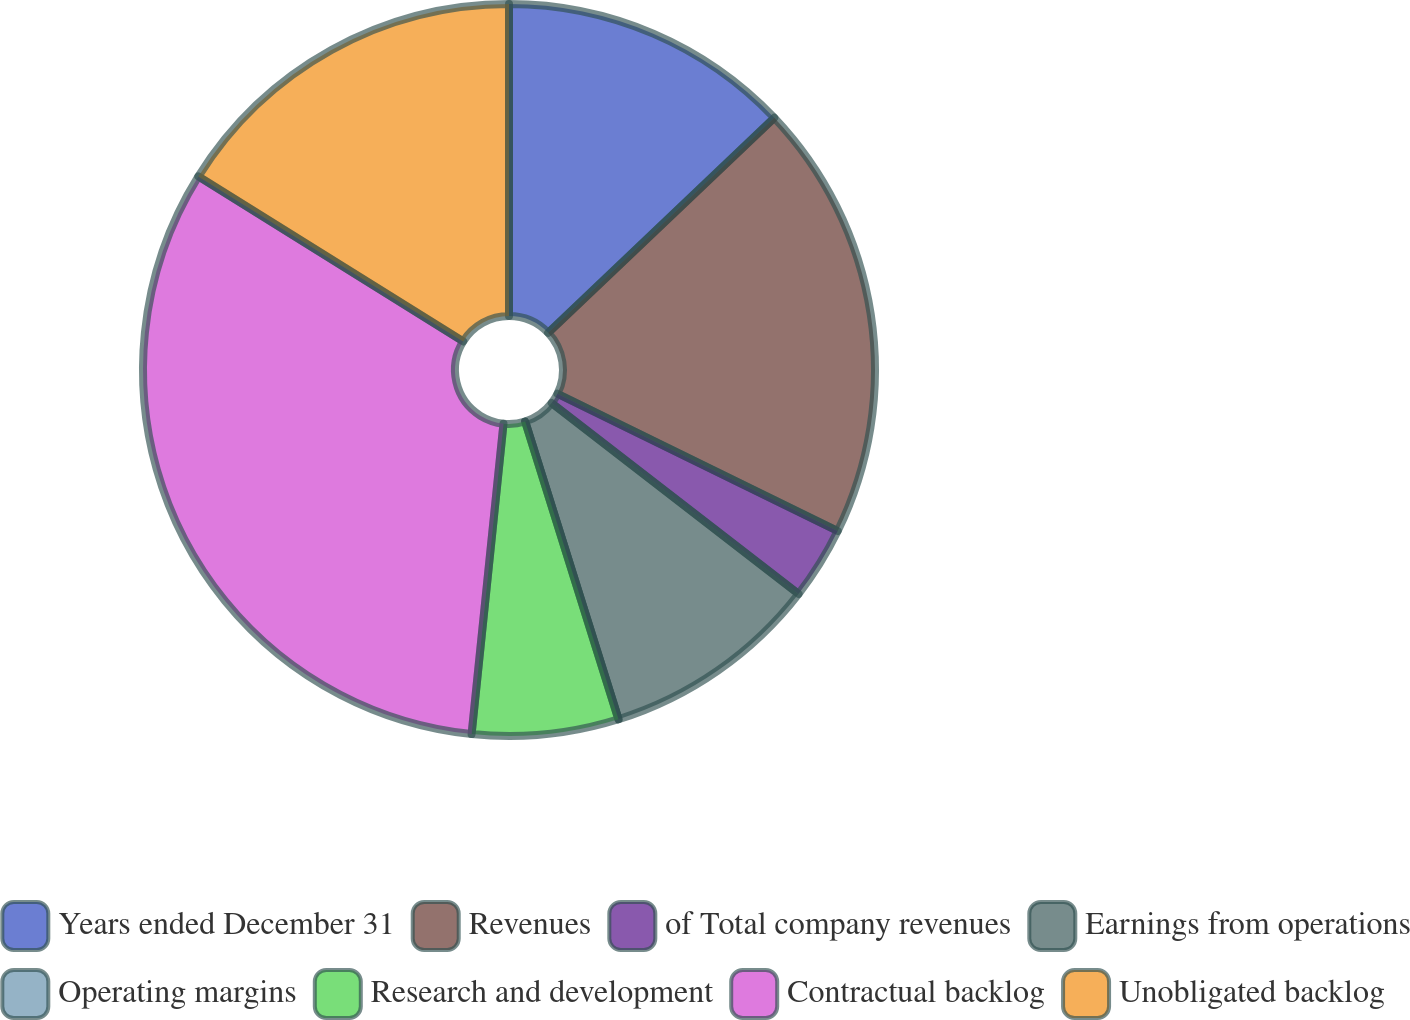Convert chart. <chart><loc_0><loc_0><loc_500><loc_500><pie_chart><fcel>Years ended December 31<fcel>Revenues<fcel>of Total company revenues<fcel>Earnings from operations<fcel>Operating margins<fcel>Research and development<fcel>Contractual backlog<fcel>Unobligated backlog<nl><fcel>12.9%<fcel>19.35%<fcel>3.23%<fcel>9.68%<fcel>0.01%<fcel>6.46%<fcel>32.24%<fcel>16.13%<nl></chart> 